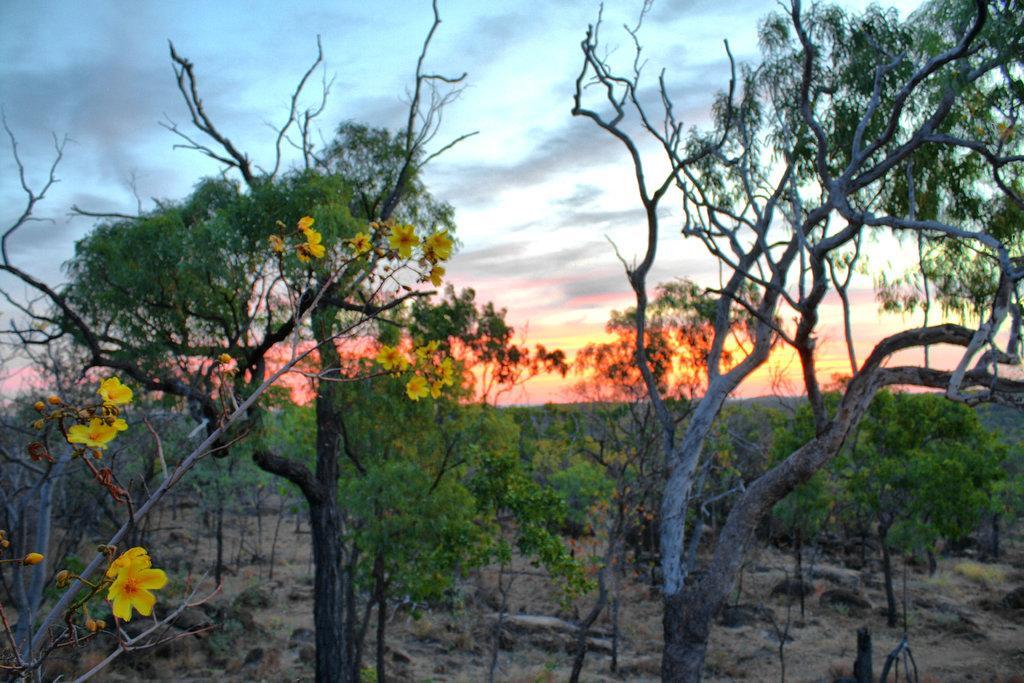Describe this image in one or two sentences. This image consists of many trees. In the front, there are flowers in yellow color. In the background, we can see the flowers in yellow color. In the background, we can see clouds in the sky. At the bottom, there is grass on the ground. 